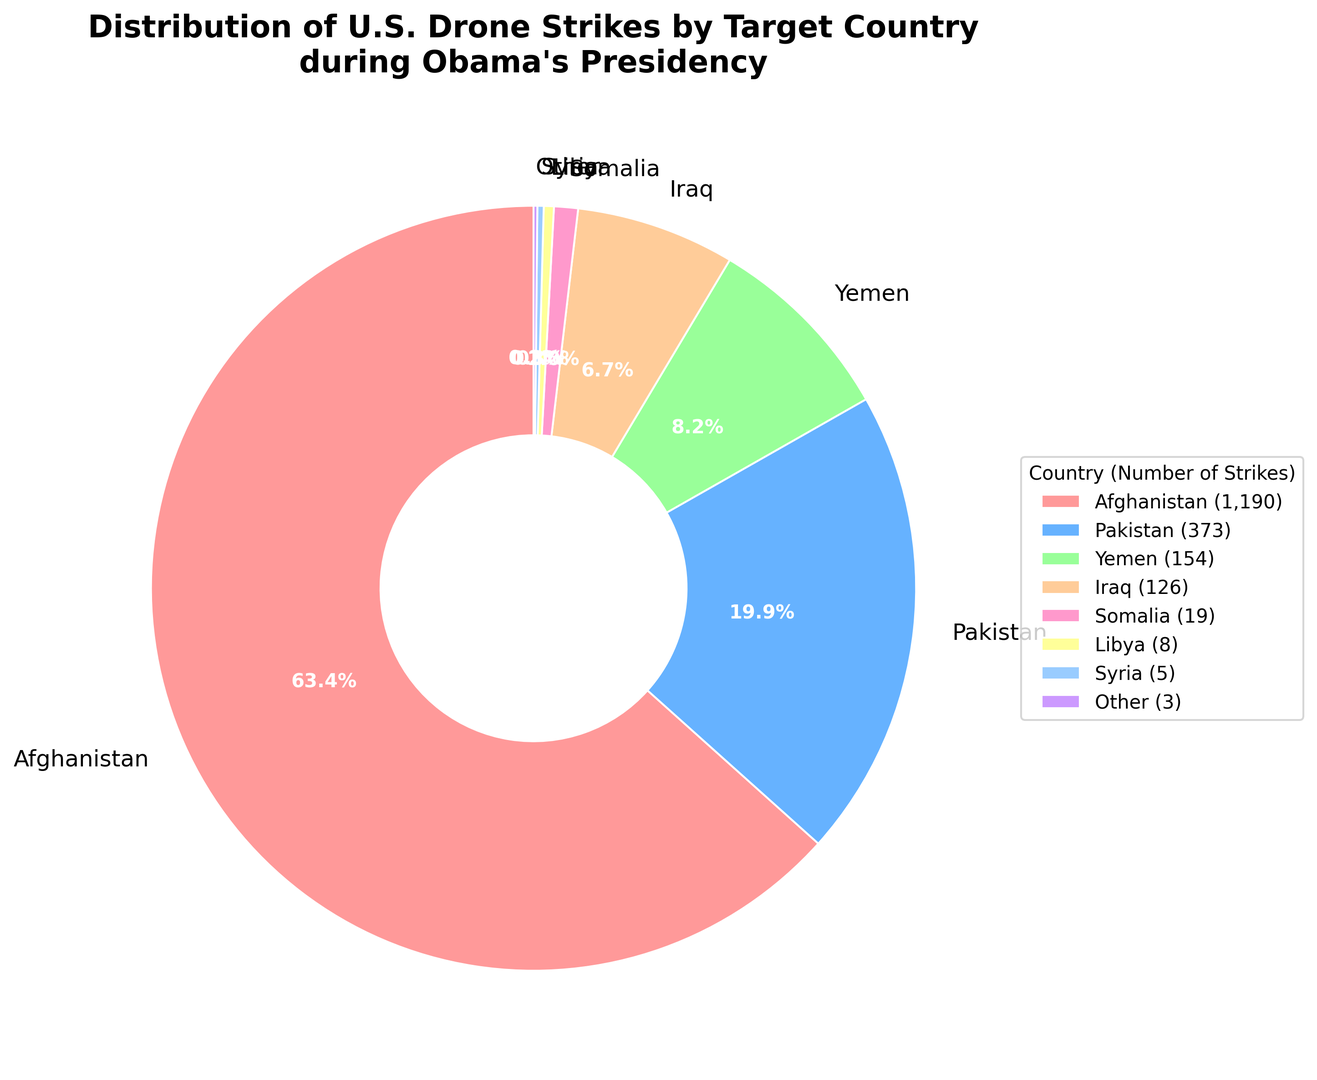Which country received the highest percentage of U.S. drone strikes during Obama's presidency? The pie chart shows different segments with percentages. The largest segment, which indicates the country with the highest percentage, is Afghanistan.
Answer: Afghanistan What is the combined percentage of drone strikes in Pakistan and Yemen? From the chart, Pakistan received 23.8% and Yemen received 9.8%. Adding these percentages: 23.8 + 9.8 = 33.6%
Answer: 33.6% How much larger is the percentage of strikes in Afghanistan compared to Iraq? Afghanistan's segment shows 55.4%, and Iraq's segment shows 5.9%. Subtracting the percentages: 55.4 - 5.9 = 49.5%
Answer: 49.5% Which countries received less than 1% of the drone strikes? The chart displays a small segment labeled as "Other," which accounts for 0.1%. This suggests that "Other" countries individually represent less than 1%.
Answer: Other In terms of visual size, which segment is the second largest, and what percentage does it represent? Visually, the second-largest segment after Afghanistan is Pakistan, which represents 23.8%.
Answer: Pakistan, 23.8% How does the number of drone strikes in Somalia compare to that in Libya? By observing the chart, Somalia's segment shows 0.9%, and Libya's segment shows 0.4%. Somalia has a larger percentage of strikes than Libya.
Answer: Somalia What is the total number of drone strikes in countries other than Afghanistan? Total strikes excluding Afghanistan: 373 (Pakistan) + 154 (Yemen) + 19 (Somalia) + 8 (Libya) + 126 (Iraq) + 5 (Syria) + 3 (Other) = 688
Answer: 688 Which country represents the smallest segment in the pie chart when excluding "Other"? By examining the segments, Syria has the smallest percentage (0.2%) among the named countries, excluding the "Other" category.
Answer: Syria What is the average percentage of strikes for Pakistan, Yemen, and Somalia combined? Pakistan: 23.8%, Yemen: 9.8%, Somalia: 0.9%. Sum of percentages: 23.8 + 9.8 + 0.9 = 34.5%. Average: 34.5 / 3 = 11.5%
Answer: 11.5% If you combine the percentages of drone strikes in Libya and Syria, does it exceed the percentage for Iraq? Libya: 0.4%, Syria: 0.2%, Combined total: 0.4 + 0.2 = 0.6%. Iraq's percentage is 5.9%, which is greater than 0.6%.
Answer: No 